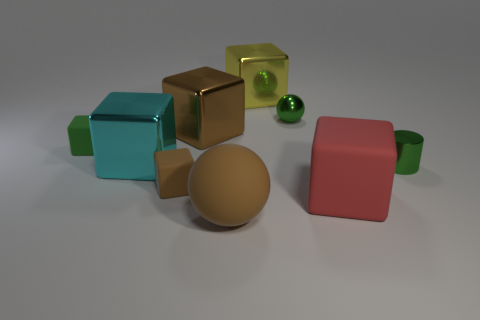Are there any shiny things of the same color as the tiny sphere?
Your answer should be very brief. Yes. Is there a tiny brown metal cylinder?
Your answer should be compact. No. There is a yellow cube left of the red matte object; is it the same size as the red rubber cube?
Your answer should be compact. Yes. Are there fewer tiny matte blocks than rubber spheres?
Make the answer very short. No. The tiny rubber object that is on the left side of the small rubber thing that is in front of the matte block that is behind the tiny green cylinder is what shape?
Your response must be concise. Cube. Are there any tiny green objects made of the same material as the big cyan object?
Offer a very short reply. Yes. There is a sphere that is in front of the green rubber cube; does it have the same color as the small matte object in front of the green metal cylinder?
Provide a short and direct response. Yes. Are there fewer green metal cylinders on the left side of the large brown rubber ball than large brown cubes?
Your response must be concise. Yes. How many objects are tiny brown cubes or metal things that are on the right side of the cyan shiny thing?
Offer a very short reply. 5. There is another tiny block that is made of the same material as the tiny brown cube; what is its color?
Give a very brief answer. Green. 